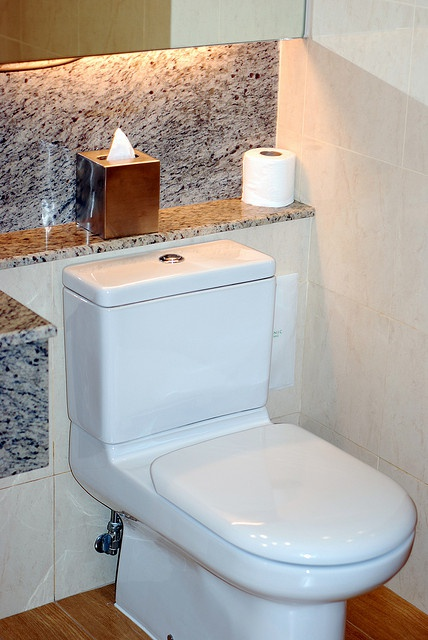Describe the objects in this image and their specific colors. I can see a toilet in maroon, lightgray, darkgray, and lightblue tones in this image. 